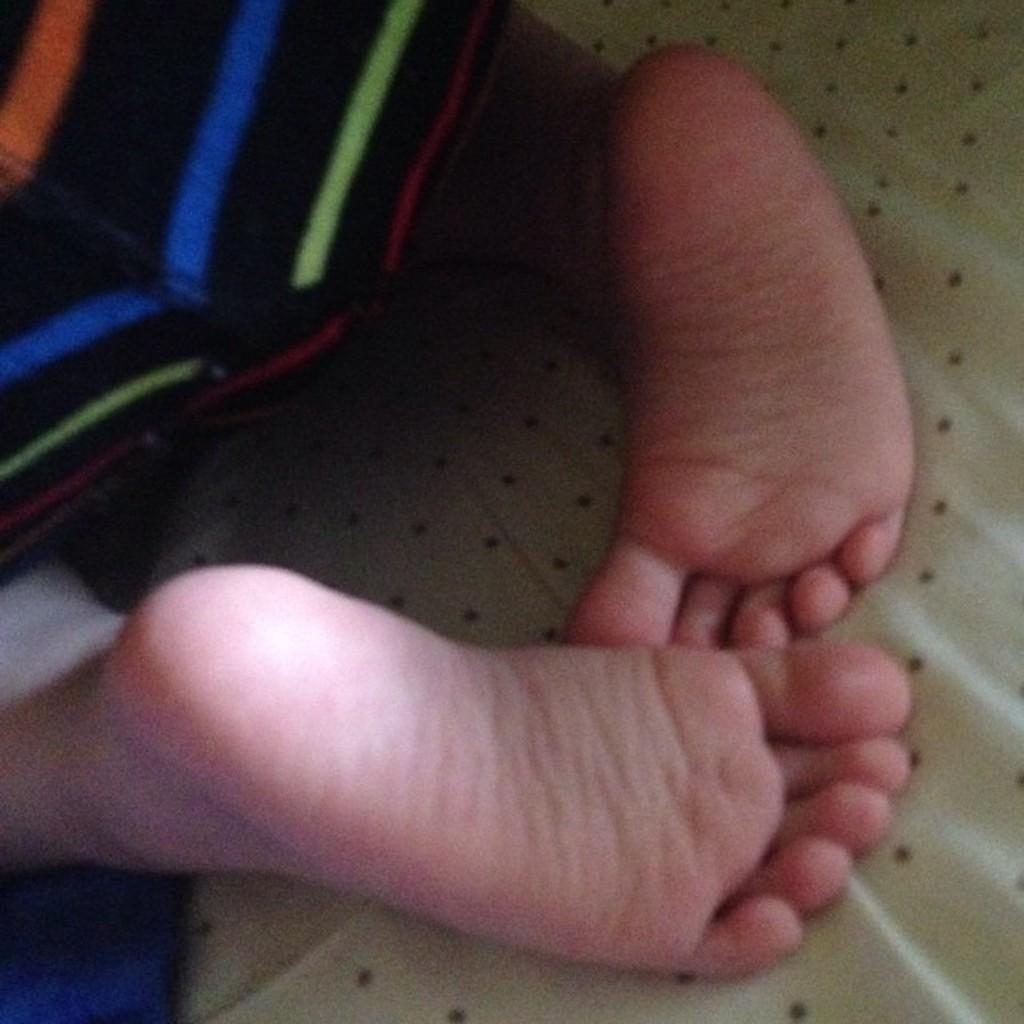What part of a baby can be seen in the image? There are two legs of a baby visible in the image. What is the baby's legs laying on in the image? The legs are laying on a cloth. What type of bat is hanging from the cloth in the image? There is no bat present in the image; it features the legs of a baby laying on a cloth. 